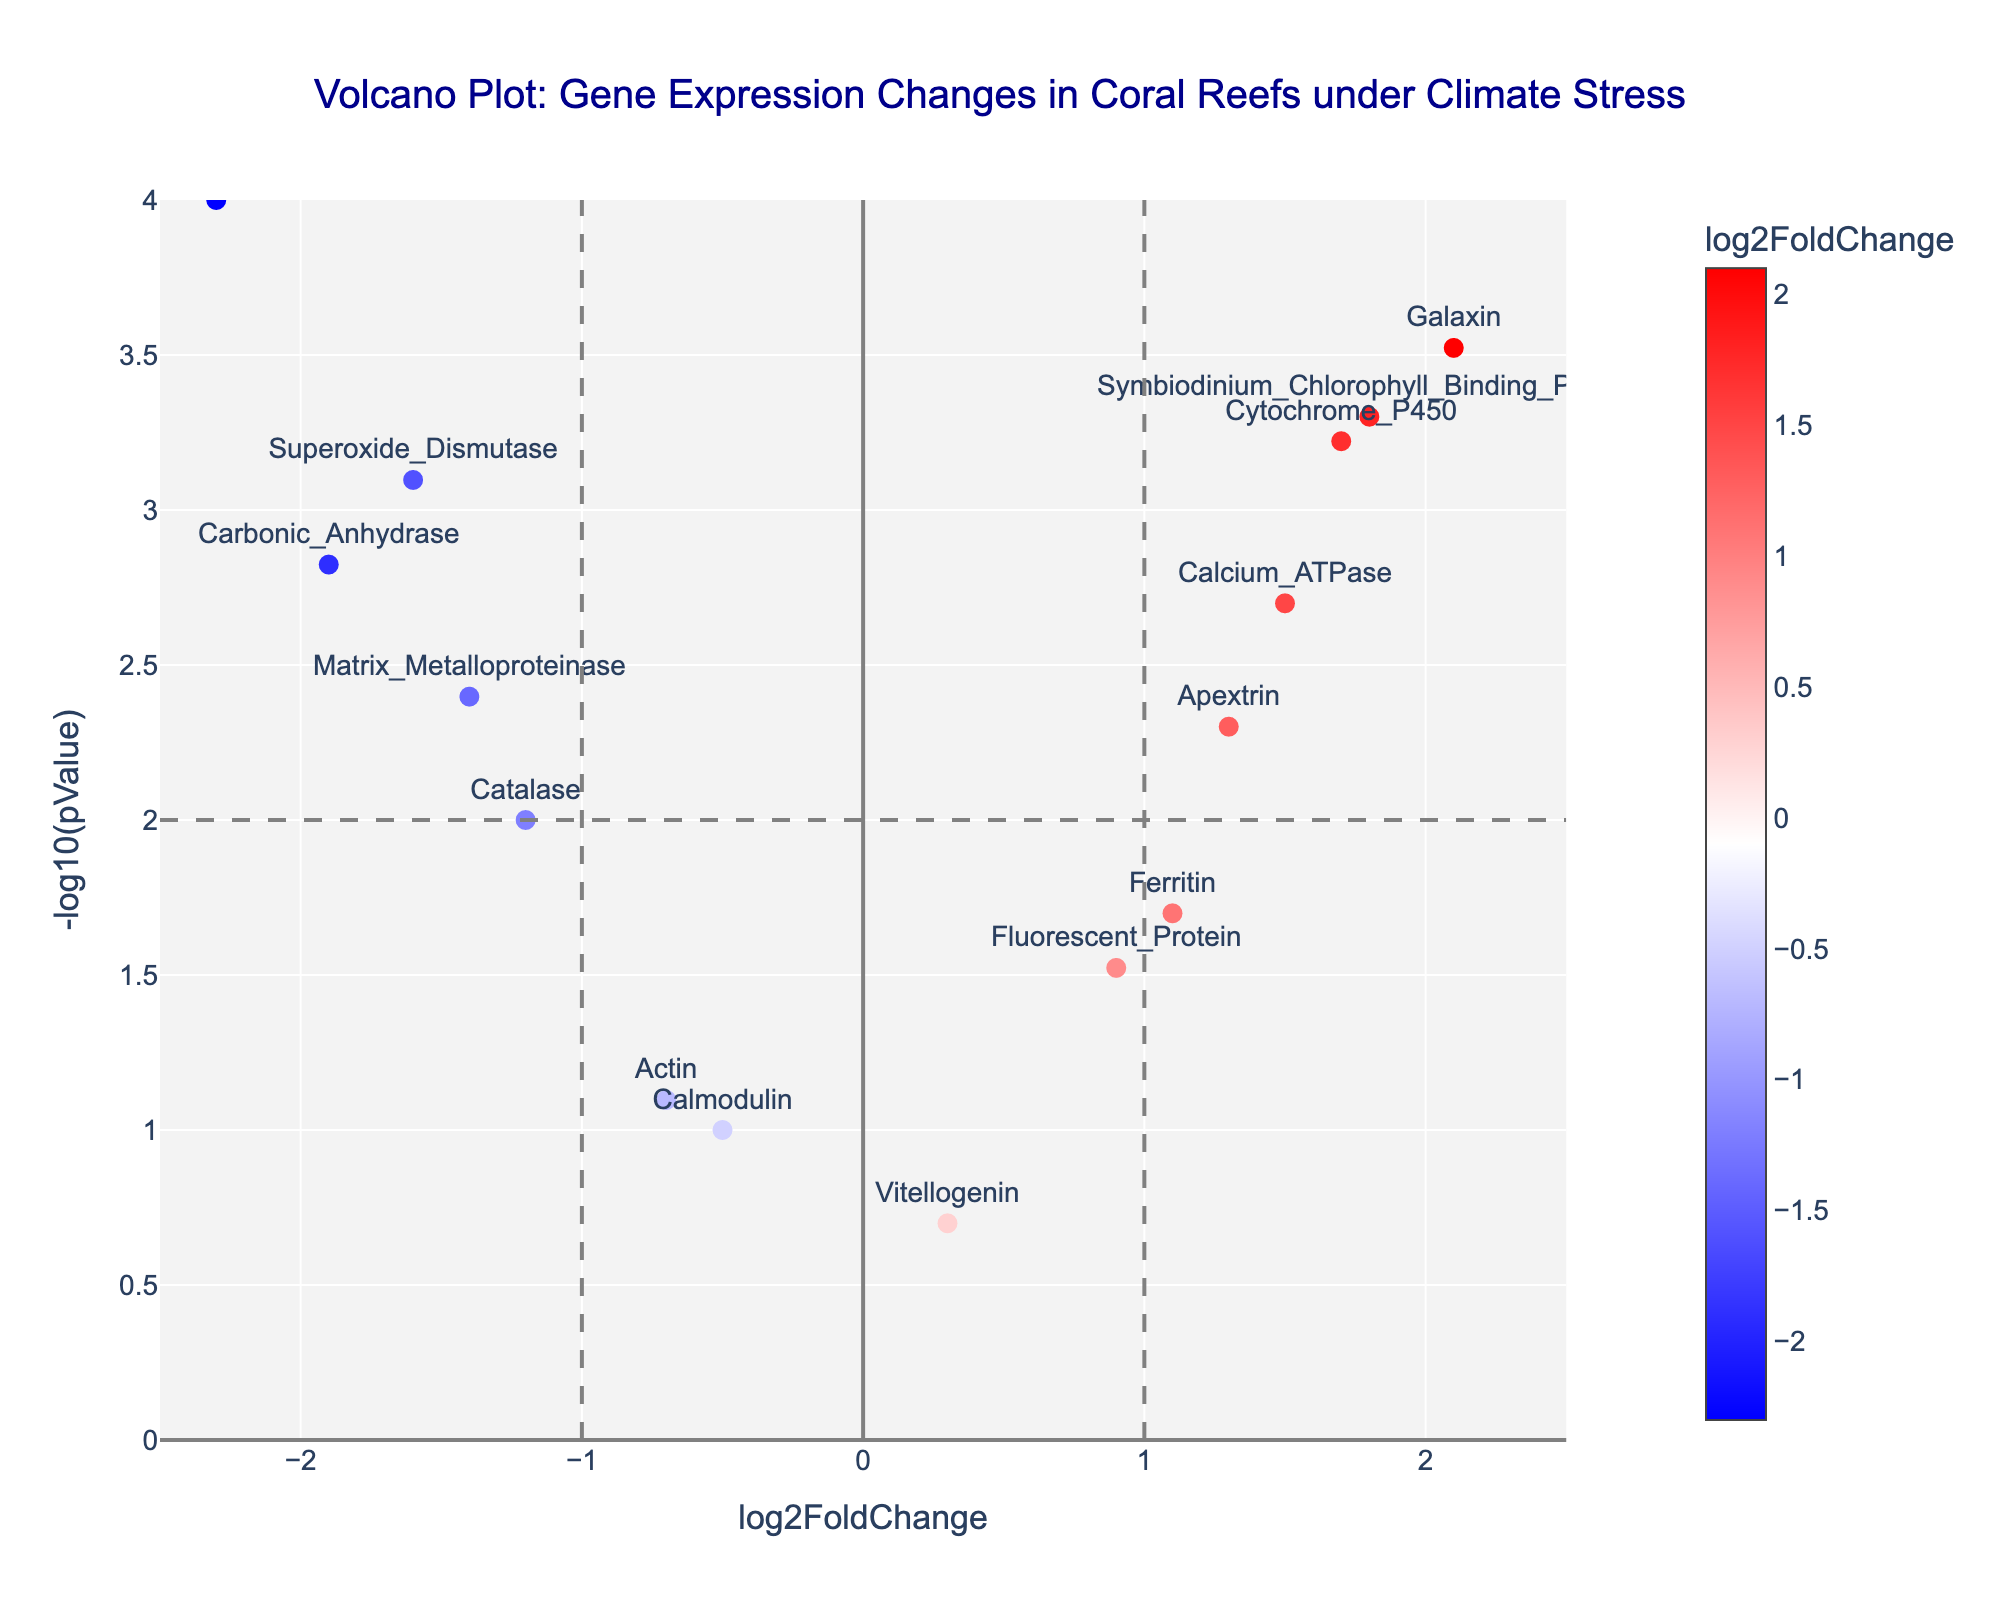What is the title of the figure? The title is presented at the top center of the figure. It reads "Volcano Plot: Gene Expression Changes in Coral Reefs under Climate Stress."
Answer: Volcano Plot: Gene Expression Changes in Coral Reefs under Climate Stress Which axis represents the log2 fold change in gene expression? The x-axis represents the log2 fold change in gene expression, as indicated by the axis label "log2FoldChange" at the bottom of the plot.
Answer: x-axis What color indicates positive log2 fold change on the plot? Positive log2 fold changes are indicated by shades of red, as shown by the right side of the color bar on the right of the plot which explains the gradient from blue (negative) to red (positive).
Answer: Red Which gene has the highest log2 fold change, and what is its value? The gene with the highest log2 fold change is "Galaxin," located at the farthest point on the positive side of the x-axis. The plot shows its log2 fold change value is approximately 2.1.
Answer: Galaxin, 2.1 How many genes have a p-value less than 0.001? The p-value threshold of 0.001 translates to -log10(pValue) greater than 3. The genes with -log10(pValue) values greater than 3 are HSP70 and Galaxin. So, there are 2 genes.
Answer: 2 What is the log2 fold change and p-value representation for the gene "Catalase"? Locate "Catalase" on the plot, observe its position along the x-axis for log2 fold change and its position along the y-axis for -log10(pValue). "Catalase" has a log2 fold change of approximately -1.2 and its -log10(pValue) is between 1 and 1.5.
Answer: -1.2, between 1 and 1.5 Which gene has the smallest p-value, and how do you know? The smallest p-value corresponds to the highest -log10(pValue) value. "HSP70" has the highest -log10(pValue) around 4, indicating it has the smallest p-value.
Answer: HSP70 Are there more upregulated or downregulated genes with significant p-values (p < 0.01)? Upregulated genes are represented on the right of the x-axis (positive values) and downregulated genes on the left (negative values). Significant p-values (<0.01) correspond to -log10(pValue) > 2.5. Count these genes based on their coordinates. There are more downregulated genes (HSP70, Carbonic_Anhydrase, Superoxide_Dismutase, and Catalase) than upregulated genes (Symbiodinium_Chlorophyll_Binding_Protein and Galaxin).
Answer: More downregulated genes Which gene is closest to the vertical line x = -1, and is it upregulated or downregulated? The vertical line at x = -1 helps segregate genes. The gene closest to -1 is "Catalase," found slightly toward the left of the line, indicating it is downregulated.
Answer: Catalase, downregulated 